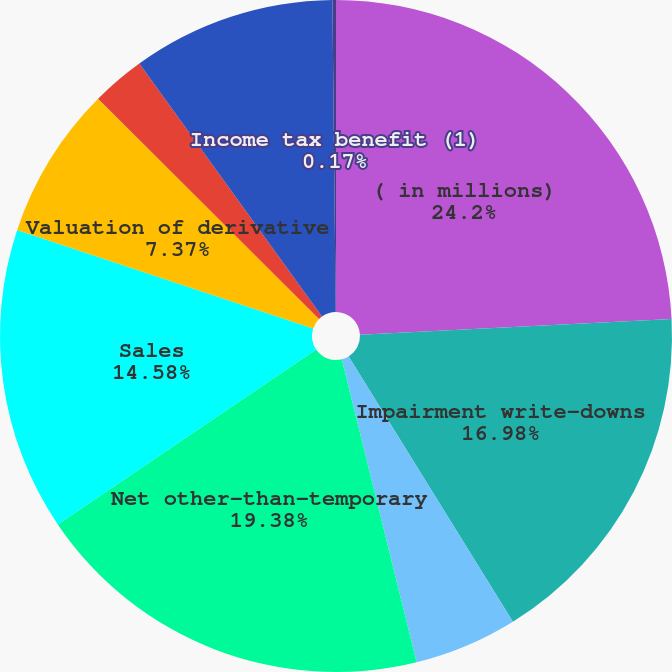Convert chart to OTSL. <chart><loc_0><loc_0><loc_500><loc_500><pie_chart><fcel>( in millions)<fcel>Impairment write-downs<fcel>Change in intent write-downs<fcel>Net other-than-temporary<fcel>Sales<fcel>Valuation of derivative<fcel>Settlements of derivative<fcel>Realized capital gains and<fcel>Income tax benefit (1)<nl><fcel>24.19%<fcel>16.98%<fcel>4.97%<fcel>19.38%<fcel>14.58%<fcel>7.37%<fcel>2.57%<fcel>9.78%<fcel>0.17%<nl></chart> 